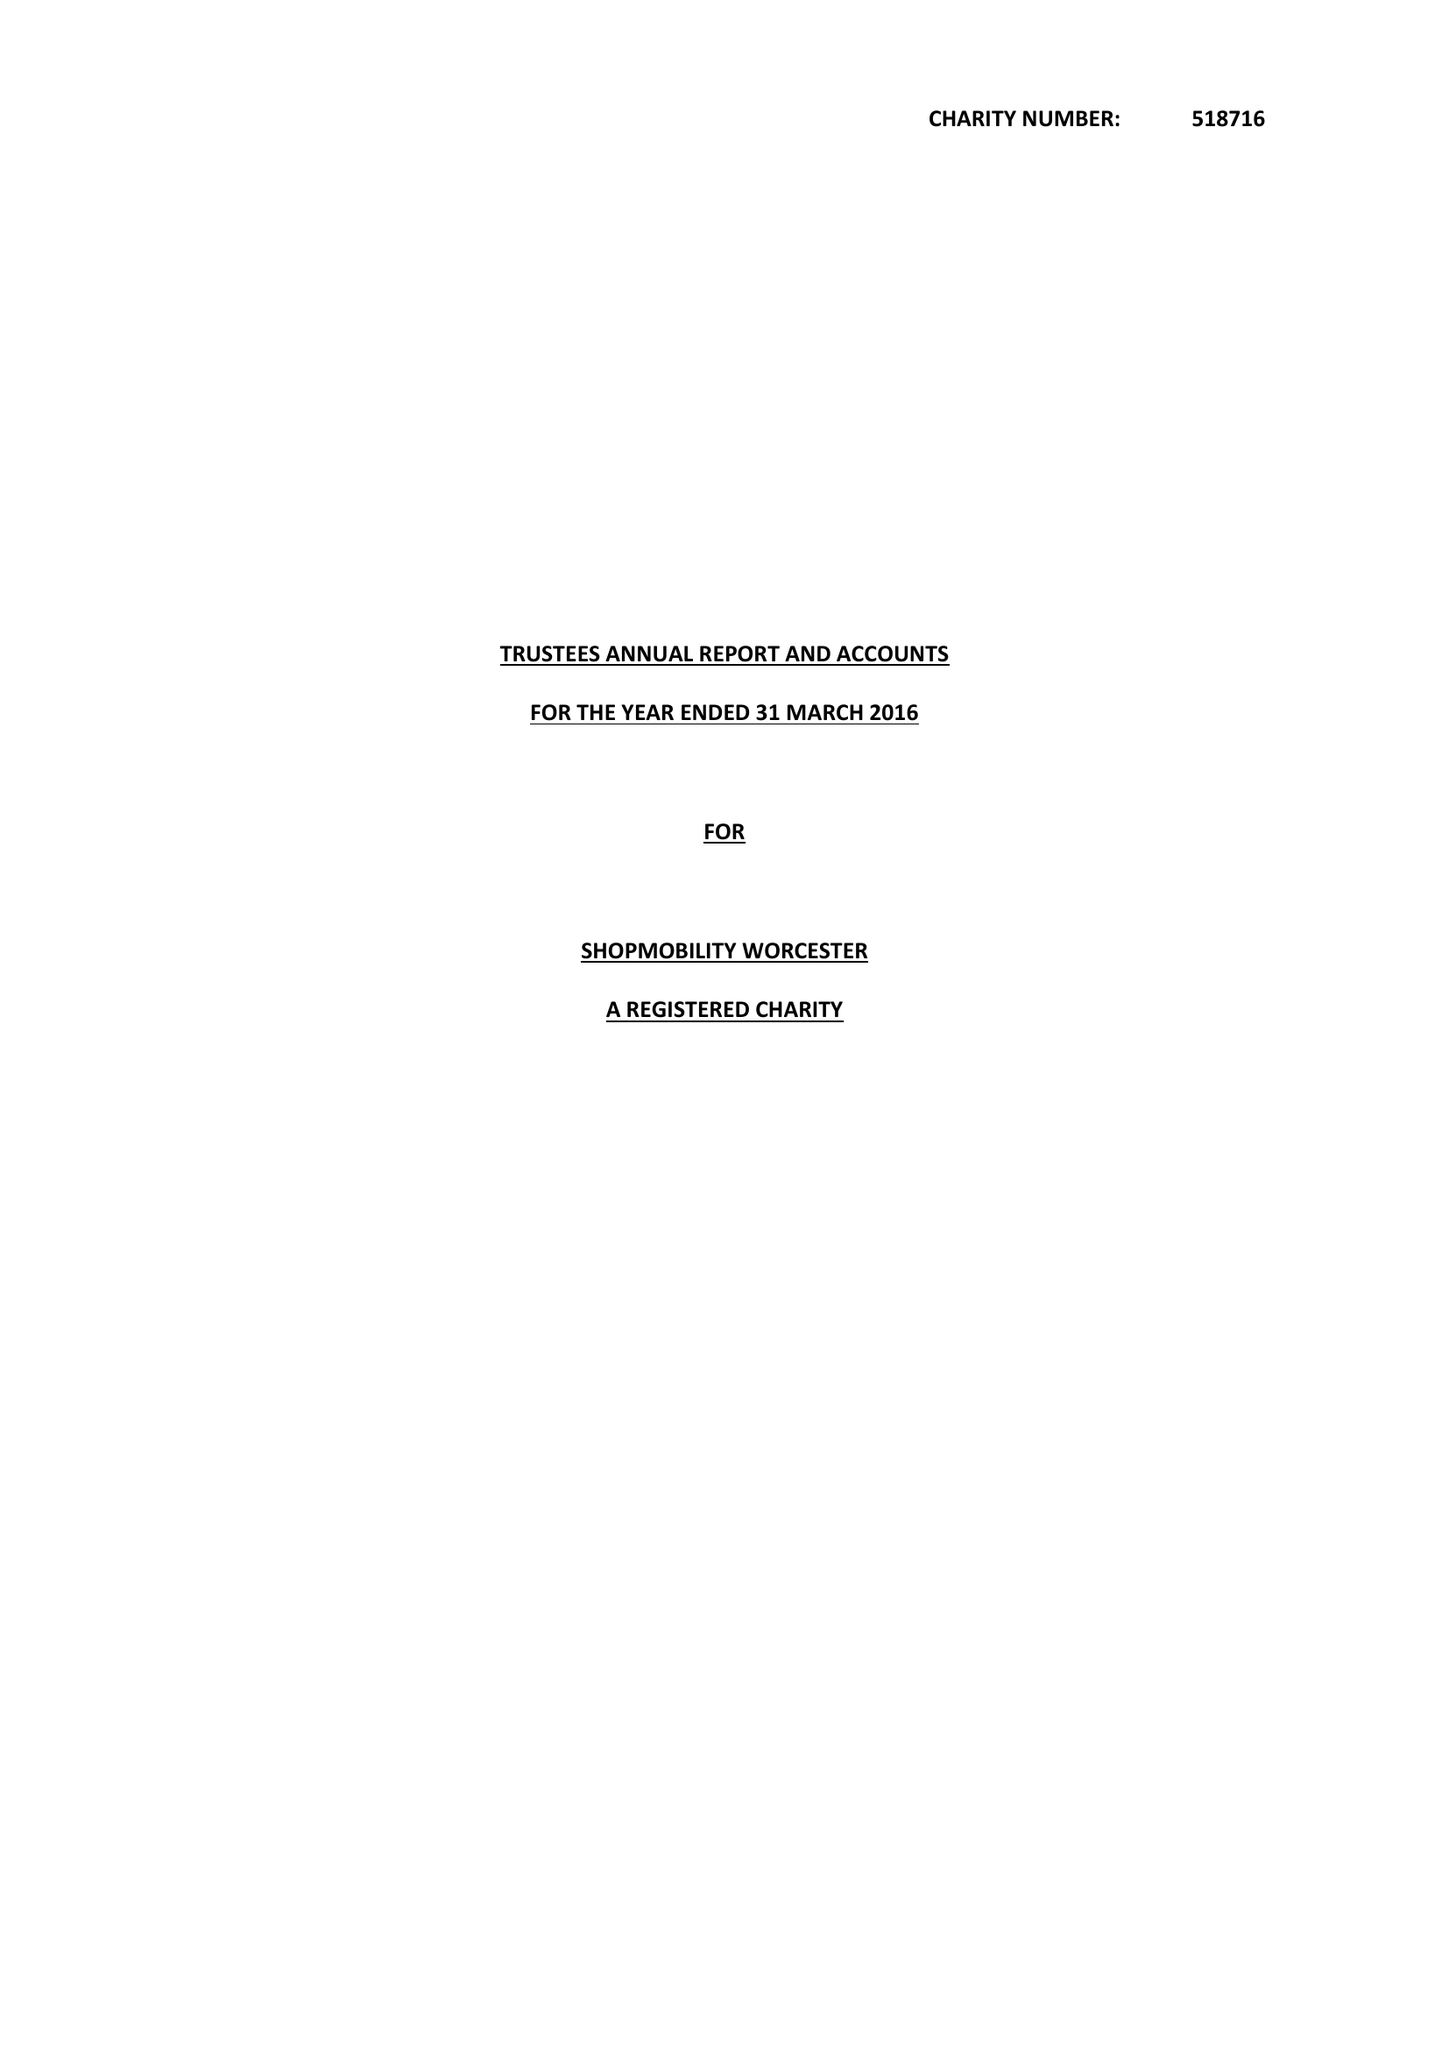What is the value for the address__postcode?
Answer the question using a single word or phrase. WR1 3LE 